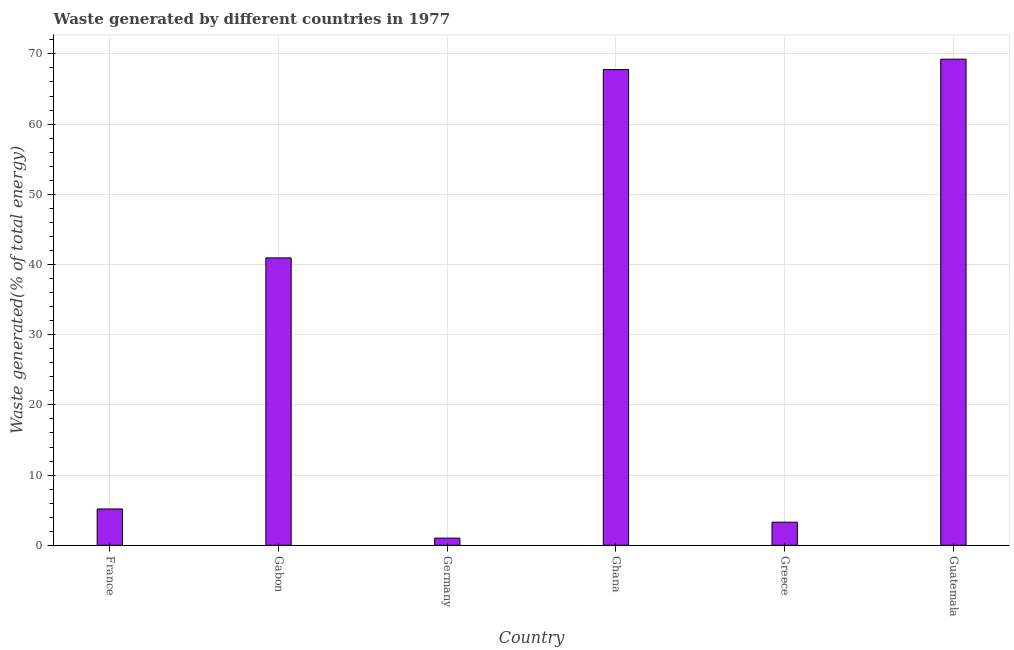Does the graph contain any zero values?
Your answer should be compact. No. Does the graph contain grids?
Ensure brevity in your answer.  Yes. What is the title of the graph?
Ensure brevity in your answer.  Waste generated by different countries in 1977. What is the label or title of the Y-axis?
Offer a very short reply. Waste generated(% of total energy). What is the amount of waste generated in Ghana?
Your answer should be very brief. 67.77. Across all countries, what is the maximum amount of waste generated?
Offer a very short reply. 69.25. Across all countries, what is the minimum amount of waste generated?
Give a very brief answer. 1.02. In which country was the amount of waste generated maximum?
Keep it short and to the point. Guatemala. What is the sum of the amount of waste generated?
Your answer should be very brief. 187.44. What is the difference between the amount of waste generated in Greece and Guatemala?
Provide a short and direct response. -65.96. What is the average amount of waste generated per country?
Your answer should be compact. 31.24. What is the median amount of waste generated?
Offer a very short reply. 23.05. Is the amount of waste generated in Greece less than that in Guatemala?
Offer a very short reply. Yes. What is the difference between the highest and the second highest amount of waste generated?
Offer a very short reply. 1.48. What is the difference between the highest and the lowest amount of waste generated?
Ensure brevity in your answer.  68.23. In how many countries, is the amount of waste generated greater than the average amount of waste generated taken over all countries?
Offer a very short reply. 3. How many bars are there?
Ensure brevity in your answer.  6. How many countries are there in the graph?
Offer a terse response. 6. What is the Waste generated(% of total energy) in France?
Your response must be concise. 5.17. What is the Waste generated(% of total energy) in Gabon?
Provide a short and direct response. 40.94. What is the Waste generated(% of total energy) of Germany?
Your answer should be very brief. 1.02. What is the Waste generated(% of total energy) of Ghana?
Keep it short and to the point. 67.77. What is the Waste generated(% of total energy) in Greece?
Provide a succinct answer. 3.29. What is the Waste generated(% of total energy) of Guatemala?
Offer a terse response. 69.25. What is the difference between the Waste generated(% of total energy) in France and Gabon?
Your response must be concise. -35.77. What is the difference between the Waste generated(% of total energy) in France and Germany?
Ensure brevity in your answer.  4.15. What is the difference between the Waste generated(% of total energy) in France and Ghana?
Your answer should be very brief. -62.6. What is the difference between the Waste generated(% of total energy) in France and Greece?
Provide a short and direct response. 1.88. What is the difference between the Waste generated(% of total energy) in France and Guatemala?
Keep it short and to the point. -64.08. What is the difference between the Waste generated(% of total energy) in Gabon and Germany?
Ensure brevity in your answer.  39.92. What is the difference between the Waste generated(% of total energy) in Gabon and Ghana?
Your answer should be very brief. -26.83. What is the difference between the Waste generated(% of total energy) in Gabon and Greece?
Ensure brevity in your answer.  37.65. What is the difference between the Waste generated(% of total energy) in Gabon and Guatemala?
Offer a terse response. -28.31. What is the difference between the Waste generated(% of total energy) in Germany and Ghana?
Ensure brevity in your answer.  -66.75. What is the difference between the Waste generated(% of total energy) in Germany and Greece?
Make the answer very short. -2.27. What is the difference between the Waste generated(% of total energy) in Germany and Guatemala?
Keep it short and to the point. -68.23. What is the difference between the Waste generated(% of total energy) in Ghana and Greece?
Keep it short and to the point. 64.48. What is the difference between the Waste generated(% of total energy) in Ghana and Guatemala?
Ensure brevity in your answer.  -1.48. What is the difference between the Waste generated(% of total energy) in Greece and Guatemala?
Offer a terse response. -65.96. What is the ratio of the Waste generated(% of total energy) in France to that in Gabon?
Your answer should be compact. 0.13. What is the ratio of the Waste generated(% of total energy) in France to that in Germany?
Your answer should be compact. 5.08. What is the ratio of the Waste generated(% of total energy) in France to that in Ghana?
Offer a terse response. 0.08. What is the ratio of the Waste generated(% of total energy) in France to that in Greece?
Offer a terse response. 1.57. What is the ratio of the Waste generated(% of total energy) in France to that in Guatemala?
Provide a short and direct response. 0.07. What is the ratio of the Waste generated(% of total energy) in Gabon to that in Germany?
Your answer should be very brief. 40.2. What is the ratio of the Waste generated(% of total energy) in Gabon to that in Ghana?
Offer a very short reply. 0.6. What is the ratio of the Waste generated(% of total energy) in Gabon to that in Greece?
Give a very brief answer. 12.45. What is the ratio of the Waste generated(% of total energy) in Gabon to that in Guatemala?
Your answer should be very brief. 0.59. What is the ratio of the Waste generated(% of total energy) in Germany to that in Ghana?
Your answer should be compact. 0.01. What is the ratio of the Waste generated(% of total energy) in Germany to that in Greece?
Keep it short and to the point. 0.31. What is the ratio of the Waste generated(% of total energy) in Germany to that in Guatemala?
Your answer should be compact. 0.01. What is the ratio of the Waste generated(% of total energy) in Ghana to that in Greece?
Offer a very short reply. 20.61. What is the ratio of the Waste generated(% of total energy) in Ghana to that in Guatemala?
Give a very brief answer. 0.98. What is the ratio of the Waste generated(% of total energy) in Greece to that in Guatemala?
Keep it short and to the point. 0.05. 